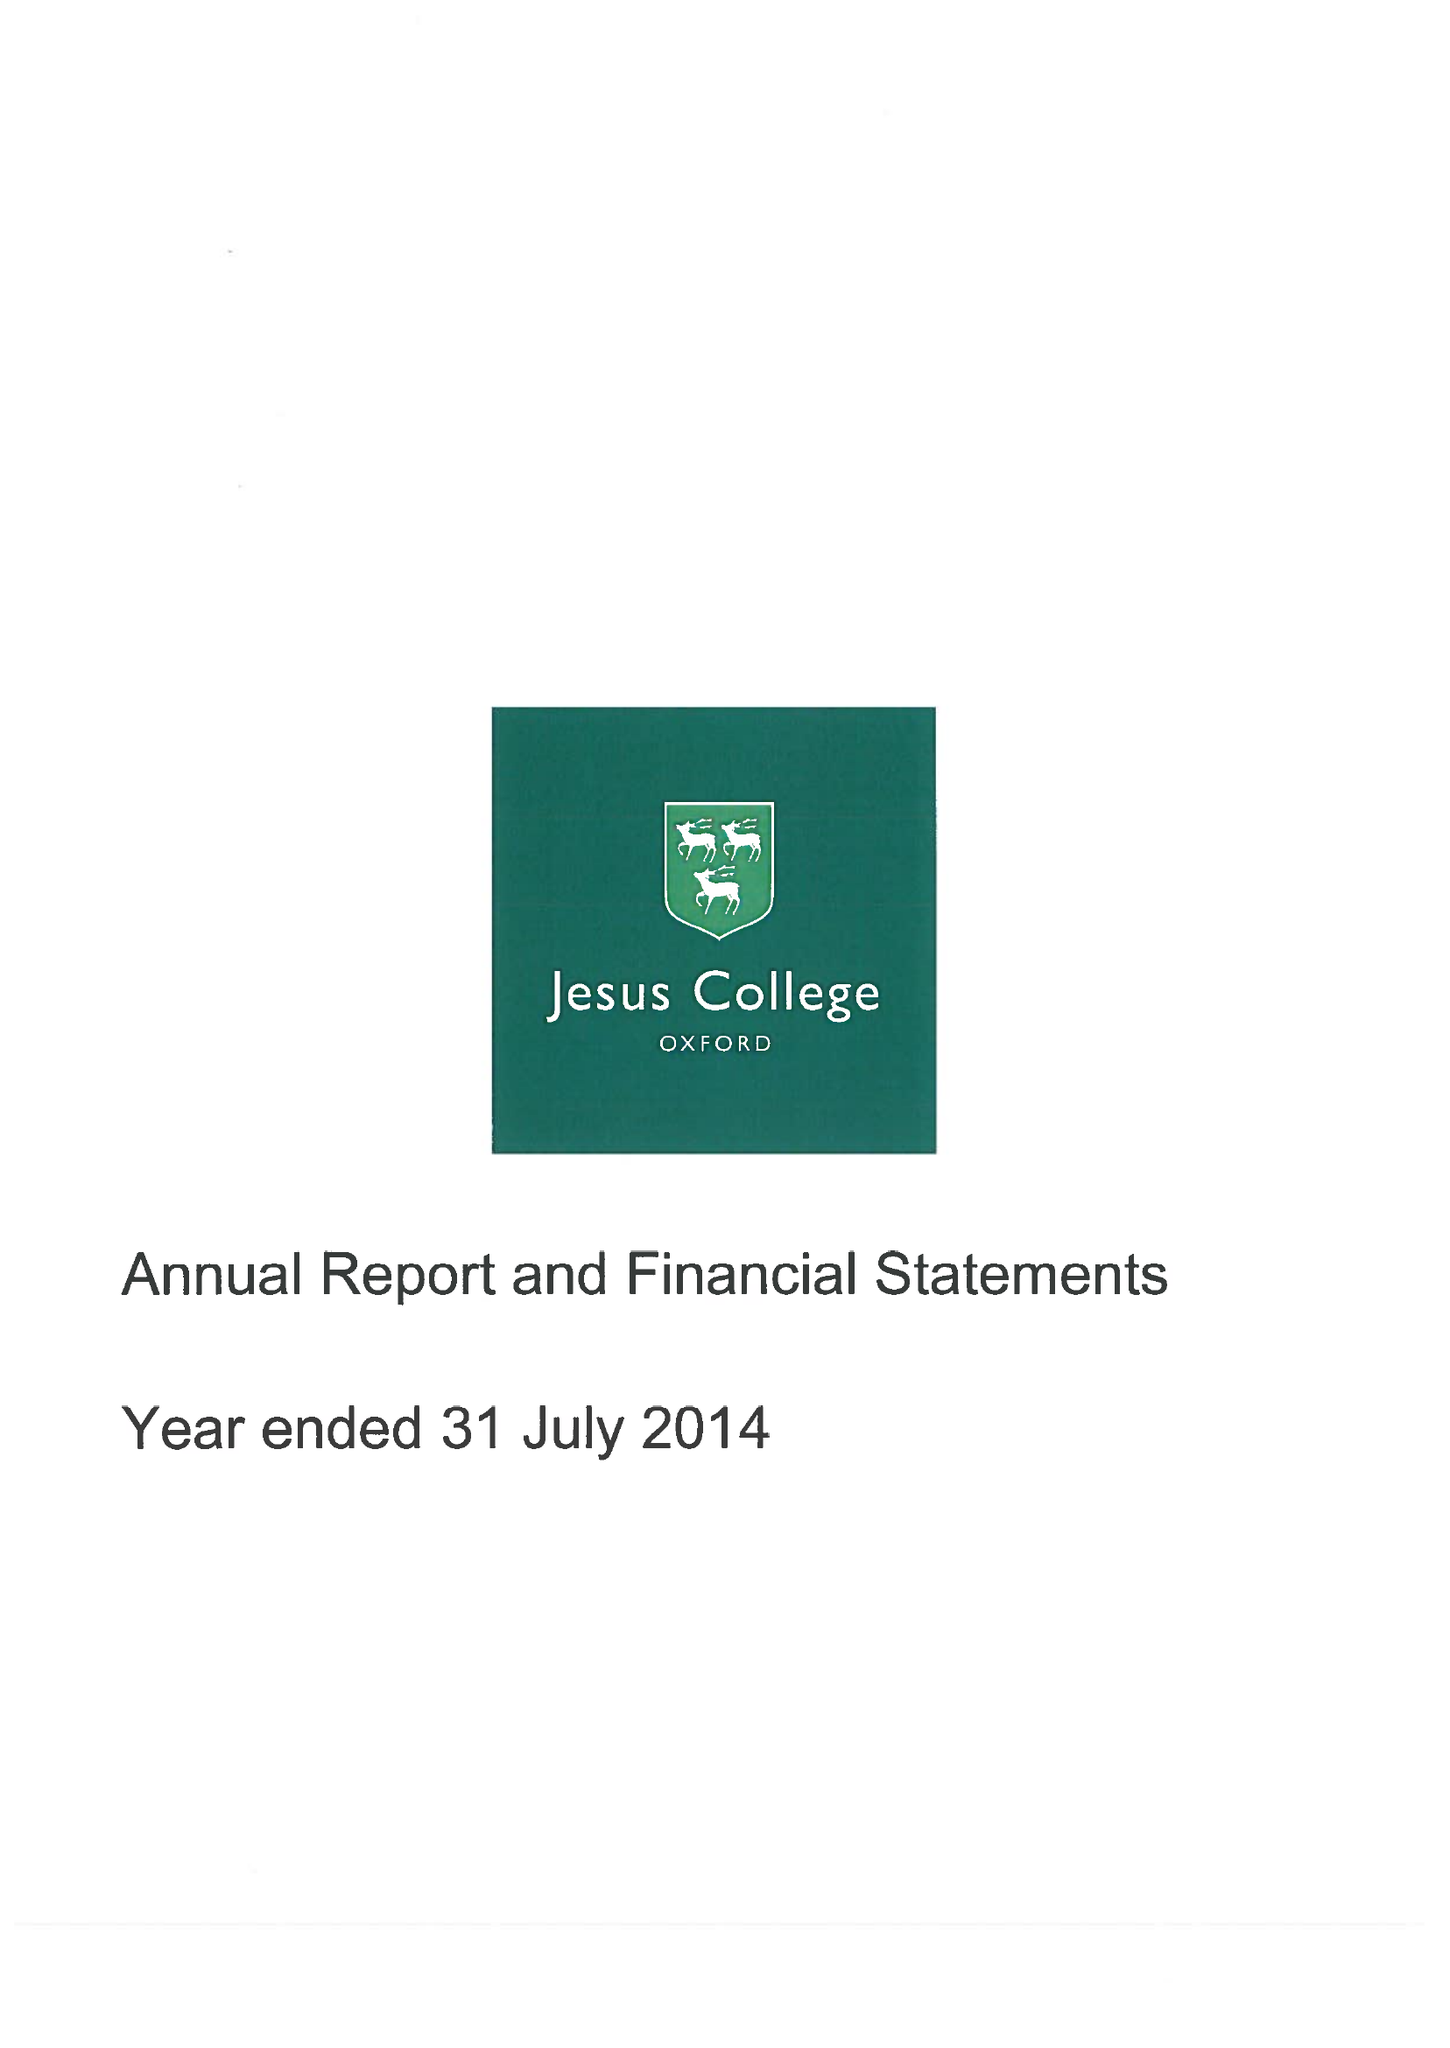What is the value for the charity_number?
Answer the question using a single word or phrase. 1137435 